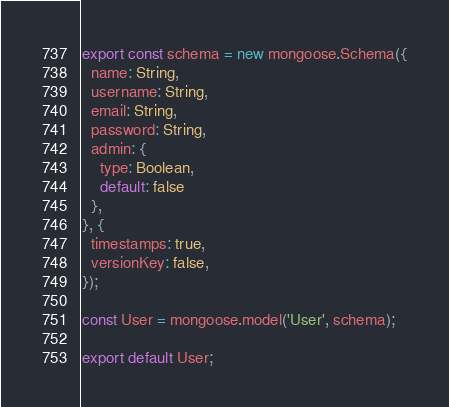Convert code to text. <code><loc_0><loc_0><loc_500><loc_500><_JavaScript_>export const schema = new mongoose.Schema({
  name: String,
  username: String,
  email: String,
  password: String,
  admin: {
    type: Boolean,
    default: false
  },
}, {
  timestamps: true,
  versionKey: false,
});

const User = mongoose.model('User', schema);

export default User;
</code> 